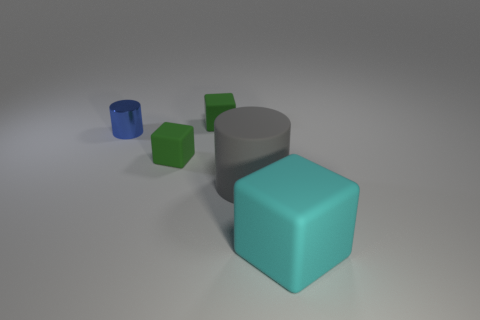Subtract all green rubber cubes. How many cubes are left? 1 Add 4 yellow rubber objects. How many objects exist? 9 Subtract all cyan blocks. How many blocks are left? 2 Subtract all green cylinders. How many green cubes are left? 2 Subtract 0 purple blocks. How many objects are left? 5 Subtract all cylinders. How many objects are left? 3 Subtract 1 cylinders. How many cylinders are left? 1 Subtract all red blocks. Subtract all gray spheres. How many blocks are left? 3 Subtract all large matte cubes. Subtract all small blue cylinders. How many objects are left? 3 Add 3 rubber cubes. How many rubber cubes are left? 6 